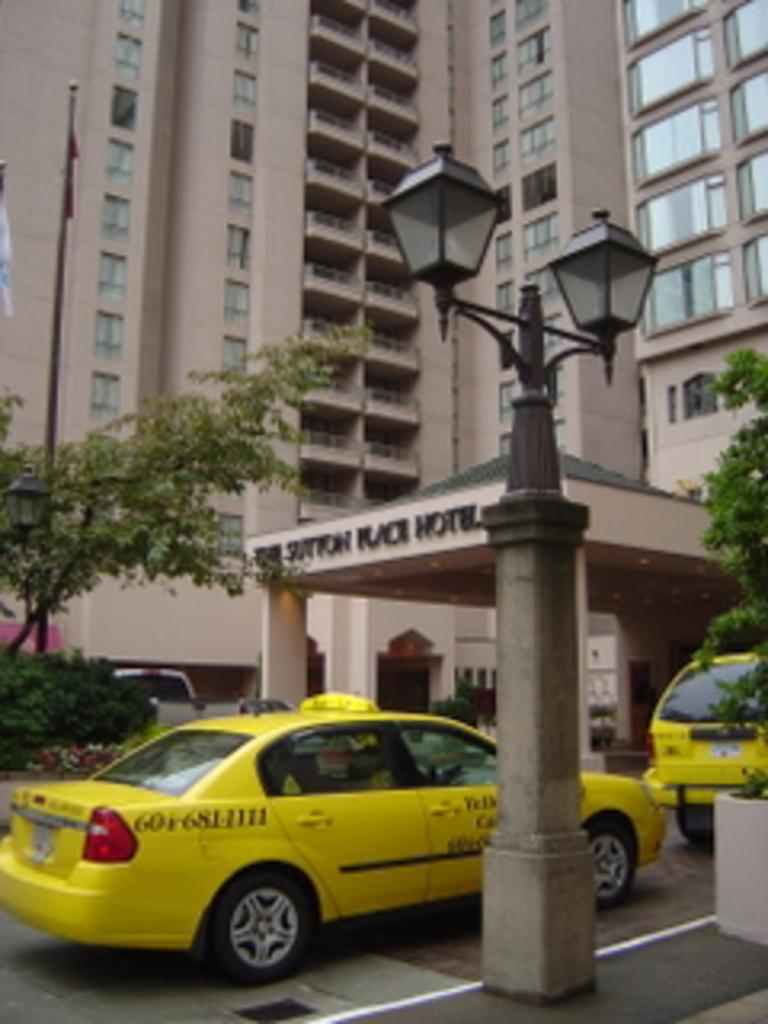<image>
Give a short and clear explanation of the subsequent image. A taxi ouside a building with the word Hotel visible. 